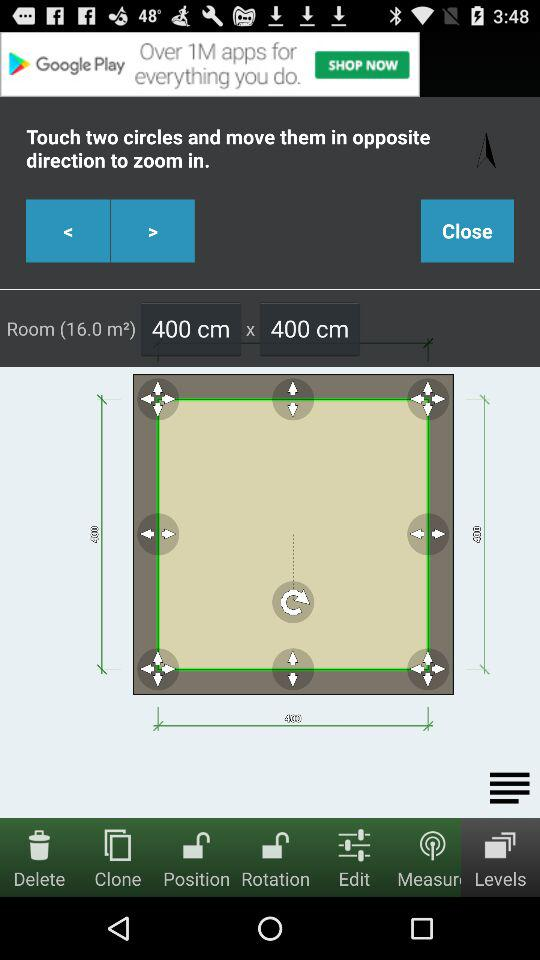Which tab is selected? The selected tab is "Levels". 